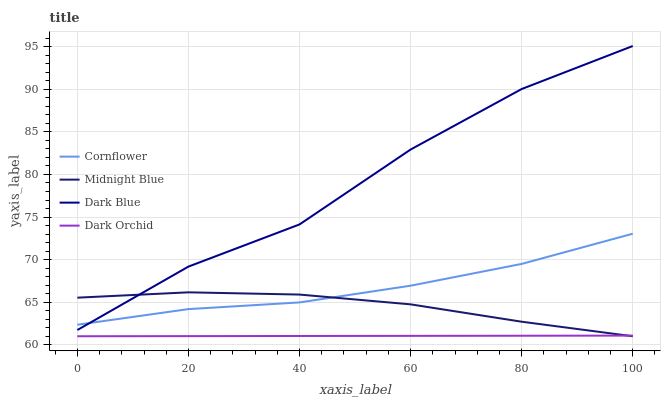Does Dark Orchid have the minimum area under the curve?
Answer yes or no. Yes. Does Dark Blue have the maximum area under the curve?
Answer yes or no. Yes. Does Midnight Blue have the minimum area under the curve?
Answer yes or no. No. Does Midnight Blue have the maximum area under the curve?
Answer yes or no. No. Is Dark Orchid the smoothest?
Answer yes or no. Yes. Is Dark Blue the roughest?
Answer yes or no. Yes. Is Midnight Blue the smoothest?
Answer yes or no. No. Is Midnight Blue the roughest?
Answer yes or no. No. Does Midnight Blue have the lowest value?
Answer yes or no. Yes. Does Dark Blue have the lowest value?
Answer yes or no. No. Does Dark Blue have the highest value?
Answer yes or no. Yes. Does Midnight Blue have the highest value?
Answer yes or no. No. Is Dark Orchid less than Cornflower?
Answer yes or no. Yes. Is Dark Blue greater than Dark Orchid?
Answer yes or no. Yes. Does Dark Blue intersect Cornflower?
Answer yes or no. Yes. Is Dark Blue less than Cornflower?
Answer yes or no. No. Is Dark Blue greater than Cornflower?
Answer yes or no. No. Does Dark Orchid intersect Cornflower?
Answer yes or no. No. 